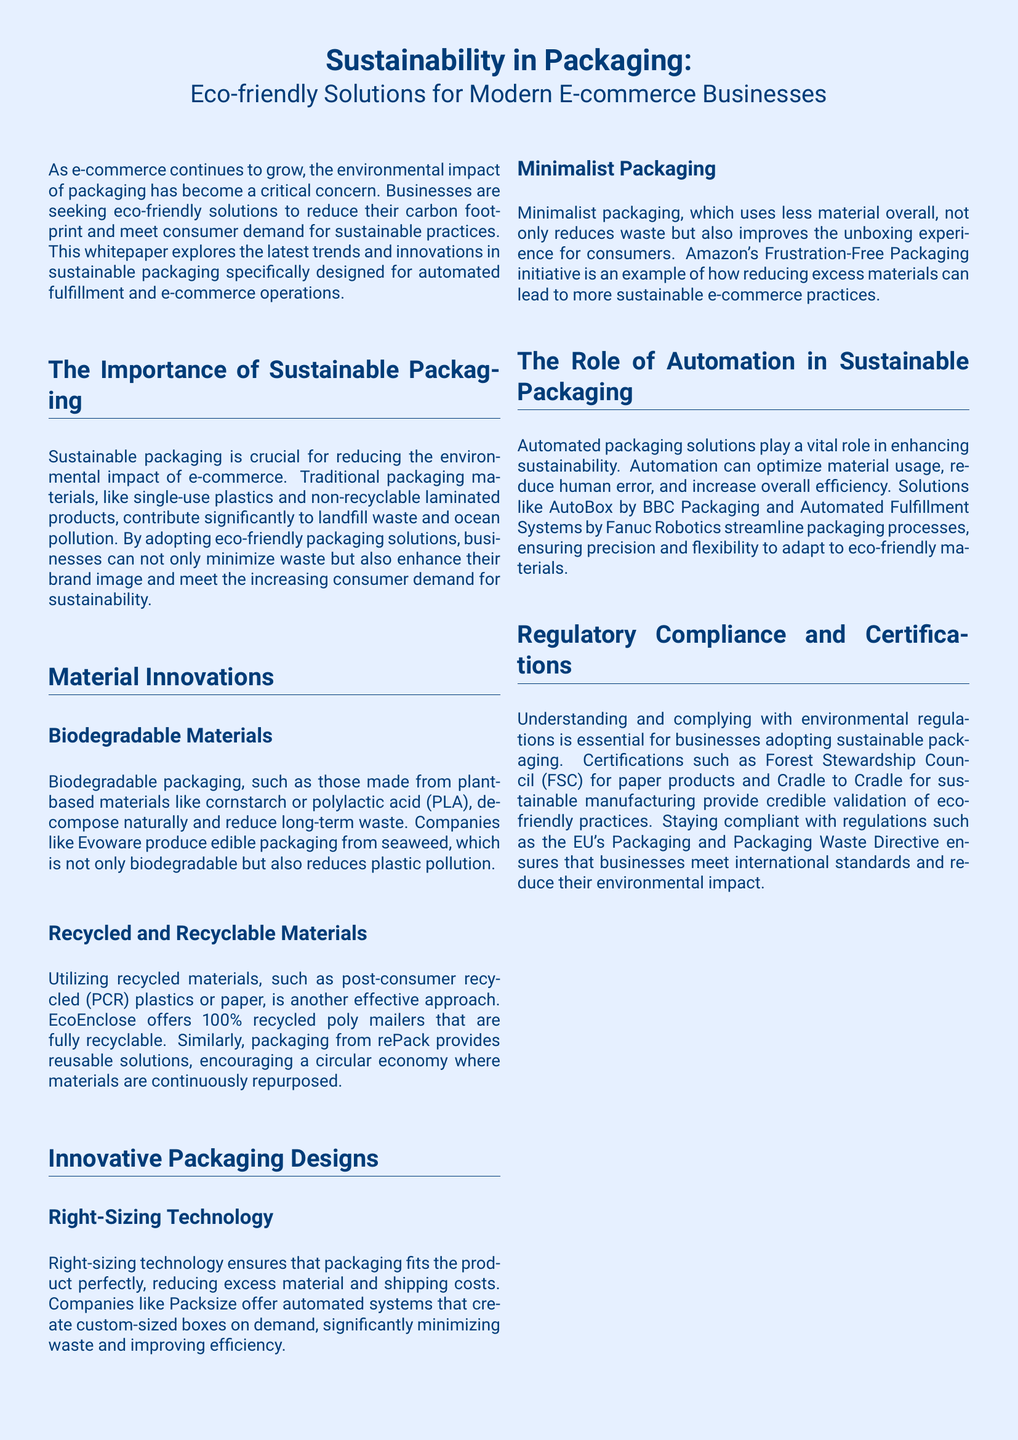What is the main topic of the whitepaper? The title of the whitepaper indicates its main topic, which is sustainability in packaging.
Answer: Sustainability in Packaging What type of materials do companies like Evoware use for biodegradable packaging? The document mentions that Evoware produces edible packaging from seaweed, which is biodegradable.
Answer: Seaweed What are the two types of eco-friendly materials highlighted in the document? The document lists biodegradable and recycled materials as the two types of eco-friendly packaging solutions.
Answer: Biodegradable and recycled What technology is used to reduce excess material in packaging? Right-sizing technology is mentioned as a way to ensure packaging fits products perfectly and minimizes waste.
Answer: Right-sizing technology Which initiative is an example of minimalist packaging by Amazon? The document references Amazon's Frustration-Free Packaging as an initiative to reduce excess materials.
Answer: Frustration-Free Packaging What certification is mentioned for paper products? The document mentions the Forest Stewardship Council (FSC) certification for paper products.
Answer: Forest Stewardship Council What packaging solution does BBC Packaging offer for sustainability? The document states that BBC Packaging offers AutoBox as a solution for sustainable packaging.
Answer: AutoBox What is the benefit of adopting sustainable packaging according to the conclusion? The conclusion states that transitioning to sustainable packaging is a significant business opportunity.
Answer: Business opportunity 